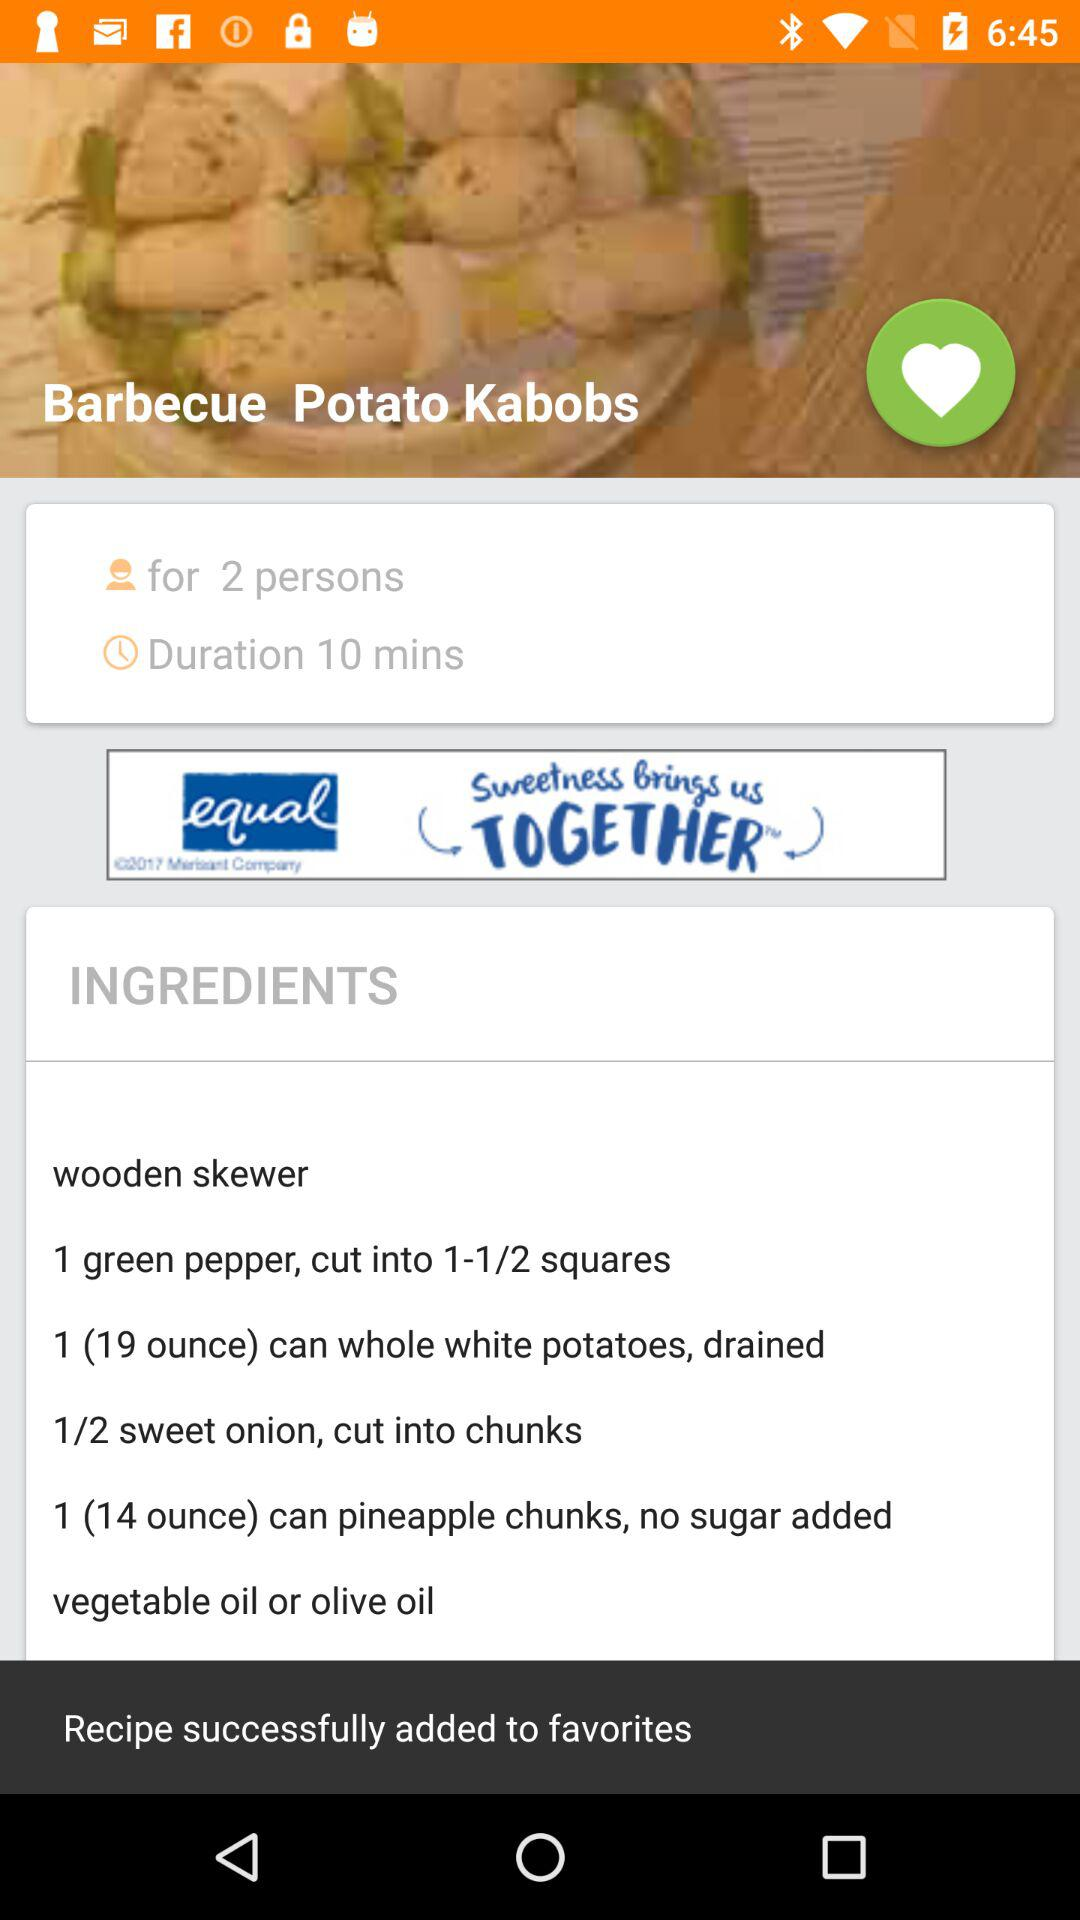How many ingredients are used for barbecue potato kabobs?
When the provided information is insufficient, respond with <no answer>. <no answer> 